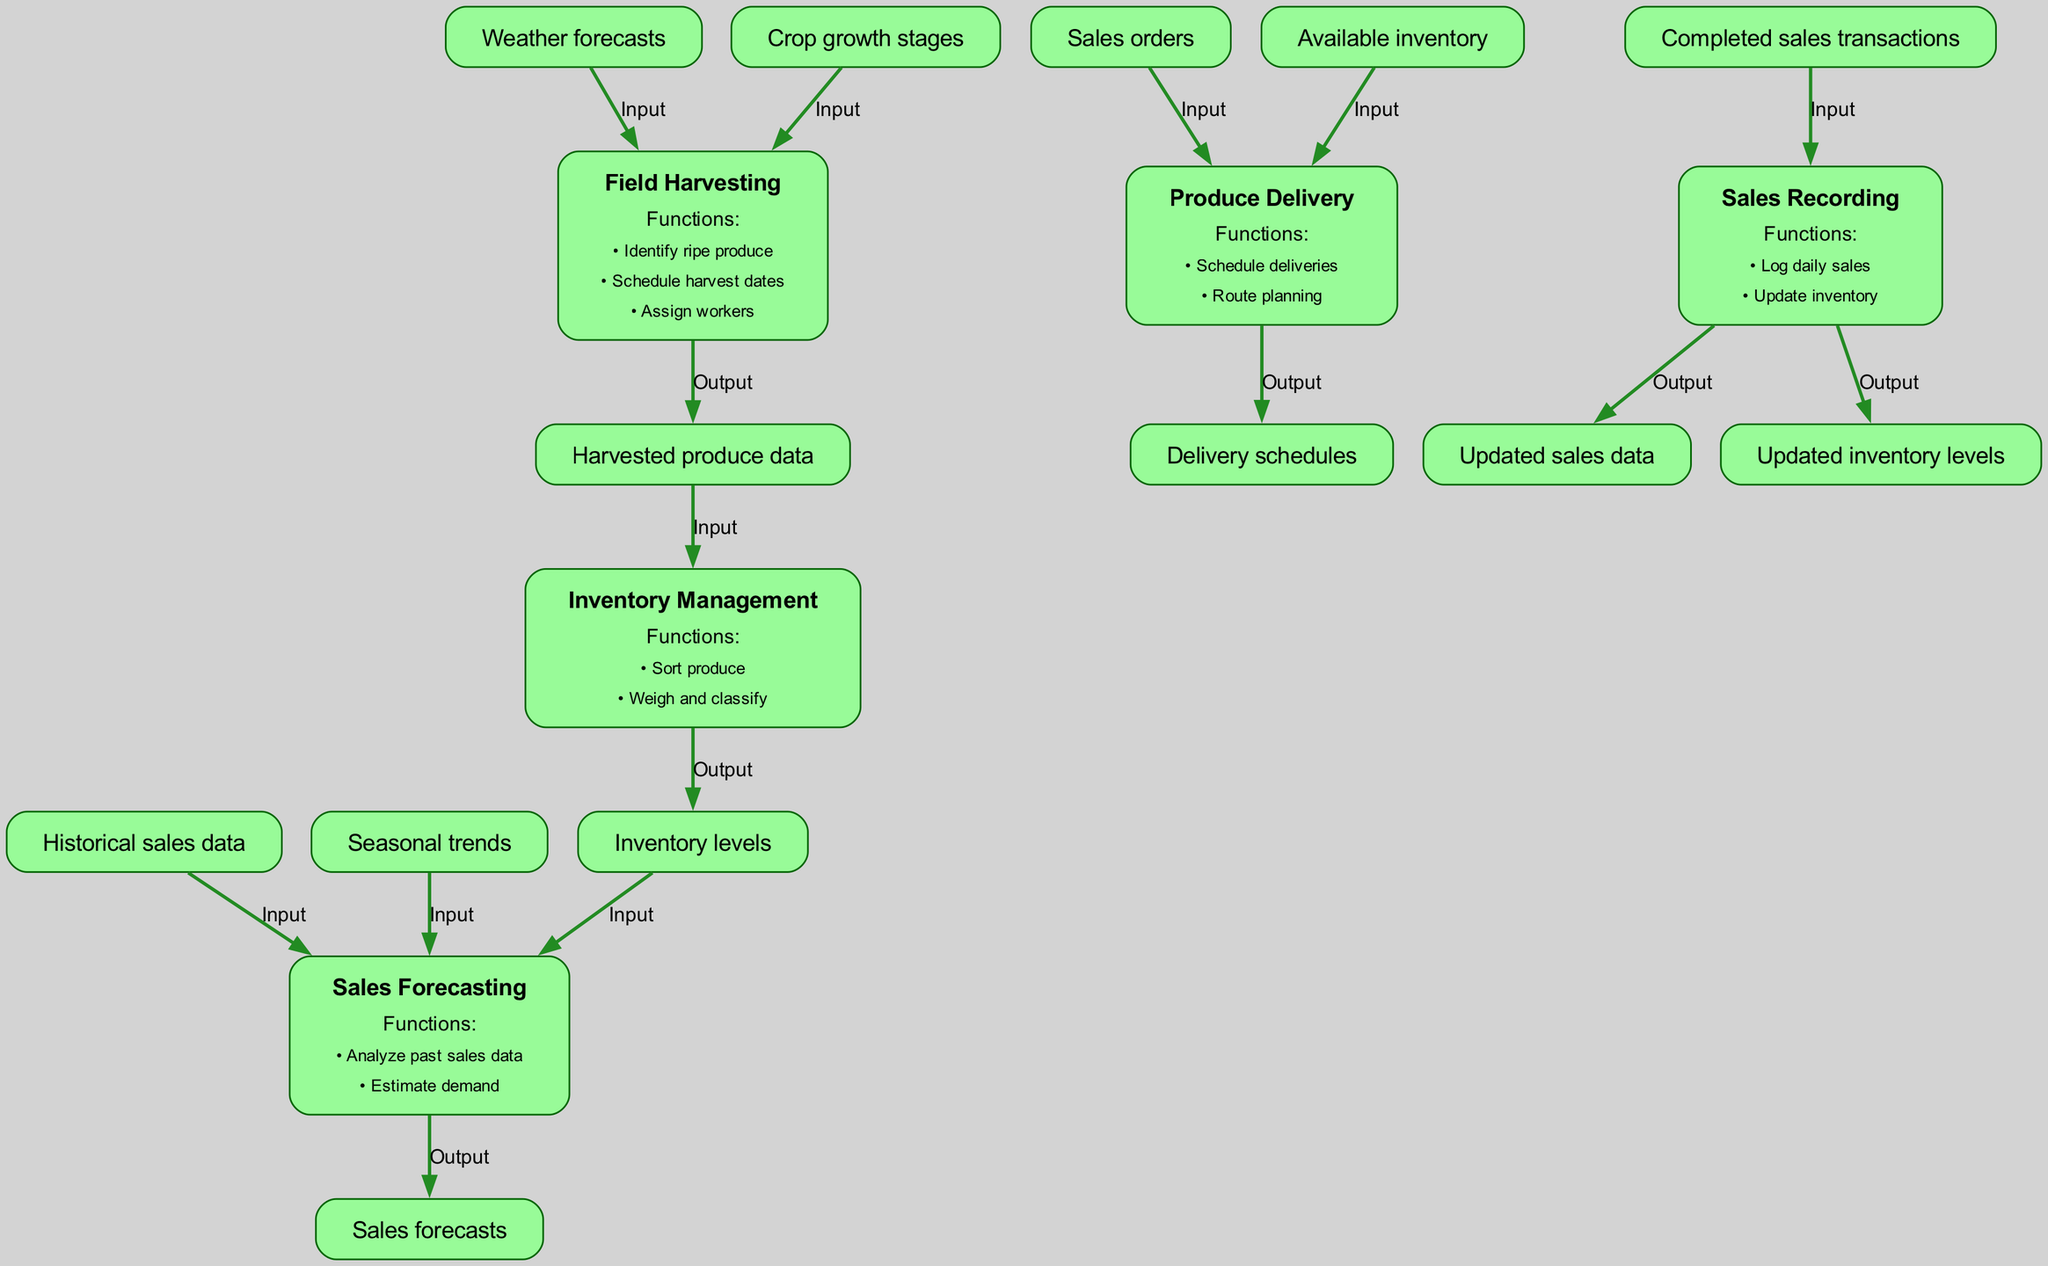What is the first step in the process? The first step in the process is "Field Harvesting" which is identified as the starting point of the diagram.
Answer: Field Harvesting How many elements are in the diagram? There are five elements in the diagram, which include Field Harvesting, Inventory Management, Sales Forecasting, Produce Delivery, and Sales Recording.
Answer: Five What is the output of the "Sales Recording" element? The outputs from the "Sales Recording" element are "Updated sales data" and "Updated inventory levels."
Answer: Updated sales data, Updated inventory levels Which element is responsible for generating sales forecasts? The element responsible for generating sales forecasts is "Sales Forecasting" which analyzes past sales data and estimates demand.
Answer: Sales Forecasting What inputs does the "Produce Delivery" element require? The "Produce Delivery" element requires inputs of "Sales orders" and "Available inventory" to determine its delivery schedules.
Answer: Sales orders, Available inventory What is the relationship between "Inventory Management" and "Sales Forecasting"? The relationship is that "Inventory Management" provides the "Inventory levels," which serve as an input to "Sales Forecasting" to estimate demand.
Answer: Inputs for sales forecasting Which function is associated with "Field Harvesting"? One of the functions associated with "Field Harvesting" is "Identify ripe produce," which is crucial for effective harvesting strategies.
Answer: Identify ripe produce How do you update the inventory levels? The inventory levels are updated by the "Sales Recording" element after logging daily sales and processing completed sales transactions.
Answer: Sales Recording What type of data does the "Sales Forecasting" analyze? The "Sales Forecasting" analyzes "Historical sales data" along with other inputs like inventory levels and seasonal trends for effective demand estimation.
Answer: Historical sales data 